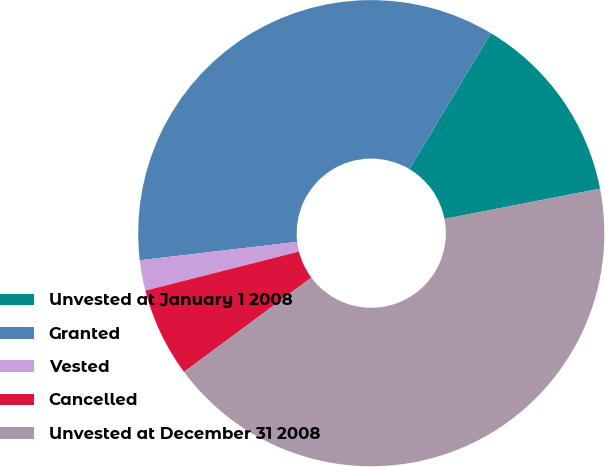Convert chart. <chart><loc_0><loc_0><loc_500><loc_500><pie_chart><fcel>Unvested at January 1 2008<fcel>Granted<fcel>Vested<fcel>Cancelled<fcel>Unvested at December 31 2008<nl><fcel>13.36%<fcel>35.44%<fcel>2.11%<fcel>6.19%<fcel>42.91%<nl></chart> 